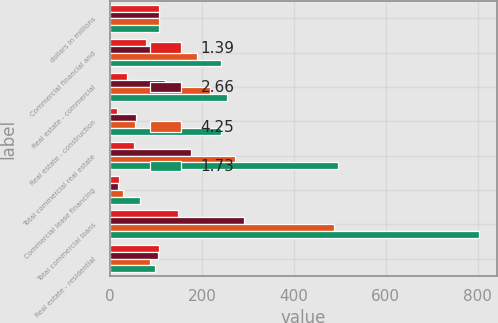Convert chart. <chart><loc_0><loc_0><loc_500><loc_500><stacked_bar_chart><ecel><fcel>dollars in millions<fcel>Commercial financial and<fcel>Real estate - commercial<fcel>Real estate - construction<fcel>Total commercial real estate<fcel>Commercial lease financing<fcel>Total commercial loans<fcel>Real estate - residential<nl><fcel>1.39<fcel>105<fcel>77<fcel>37<fcel>14<fcel>51<fcel>19<fcel>147<fcel>107<nl><fcel>2.66<fcel>105<fcel>99<fcel>120<fcel>56<fcel>176<fcel>16<fcel>291<fcel>103<nl><fcel>4.25<fcel>105<fcel>188<fcel>218<fcel>54<fcel>272<fcel>27<fcel>487<fcel>87<nl><fcel>1.73<fcel>105<fcel>242<fcel>255<fcel>241<fcel>496<fcel>64<fcel>802<fcel>98<nl></chart> 